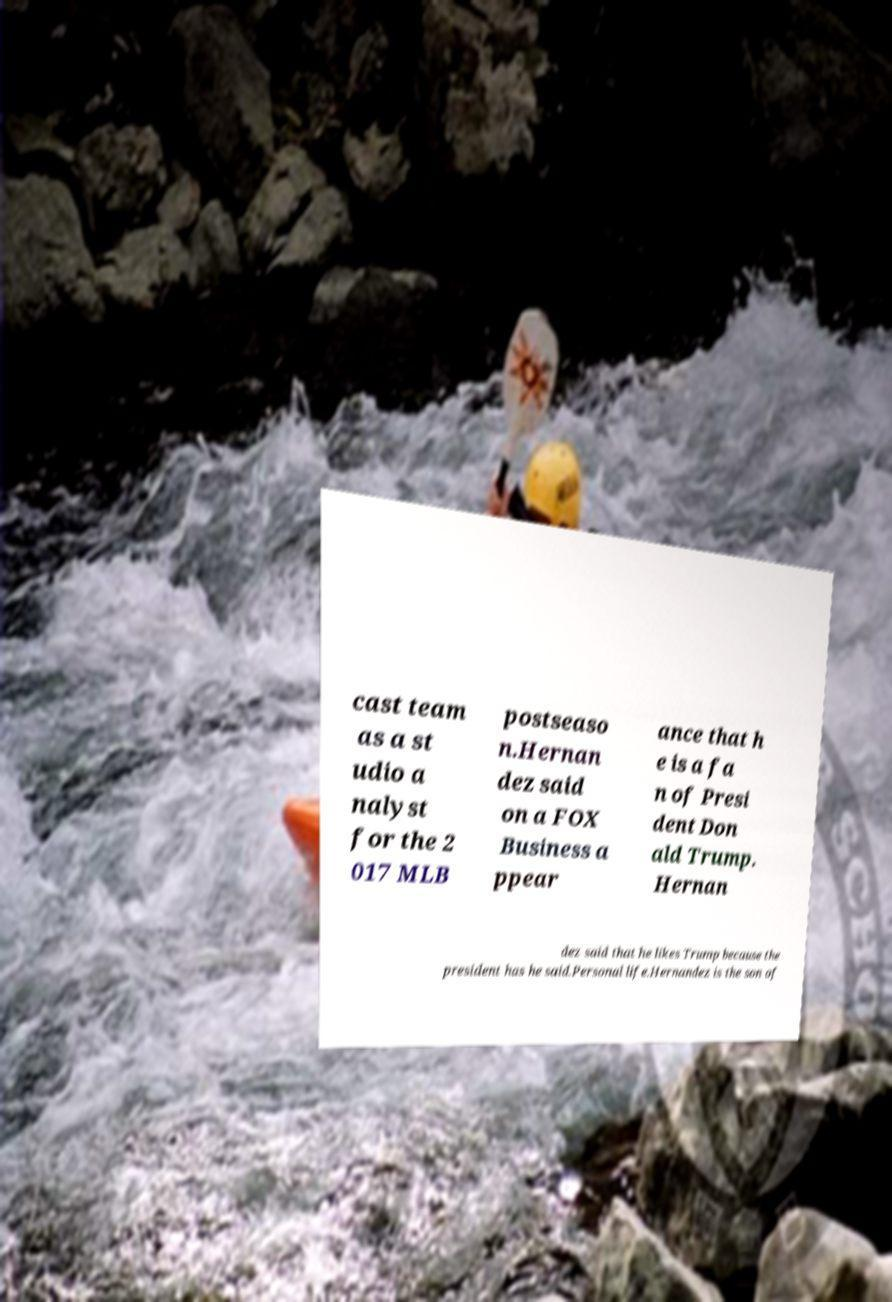Can you read and provide the text displayed in the image?This photo seems to have some interesting text. Can you extract and type it out for me? cast team as a st udio a nalyst for the 2 017 MLB postseaso n.Hernan dez said on a FOX Business a ppear ance that h e is a fa n of Presi dent Don ald Trump. Hernan dez said that he likes Trump because the president has he said.Personal life.Hernandez is the son of 